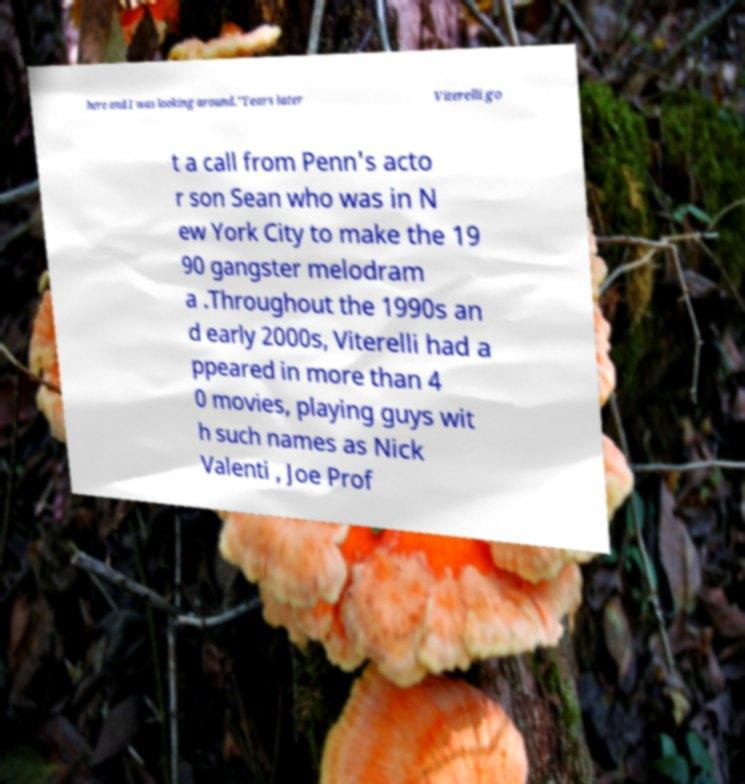For documentation purposes, I need the text within this image transcribed. Could you provide that? here and I was looking around."Years later Viterelli go t a call from Penn's acto r son Sean who was in N ew York City to make the 19 90 gangster melodram a .Throughout the 1990s an d early 2000s, Viterelli had a ppeared in more than 4 0 movies, playing guys wit h such names as Nick Valenti , Joe Prof 